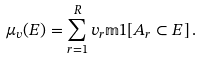<formula> <loc_0><loc_0><loc_500><loc_500>\mu _ { v } ( E ) = \sum _ { r = 1 } ^ { R } v _ { r } \mathbb { m } { 1 } [ A _ { r } \subset E ] \, .</formula> 